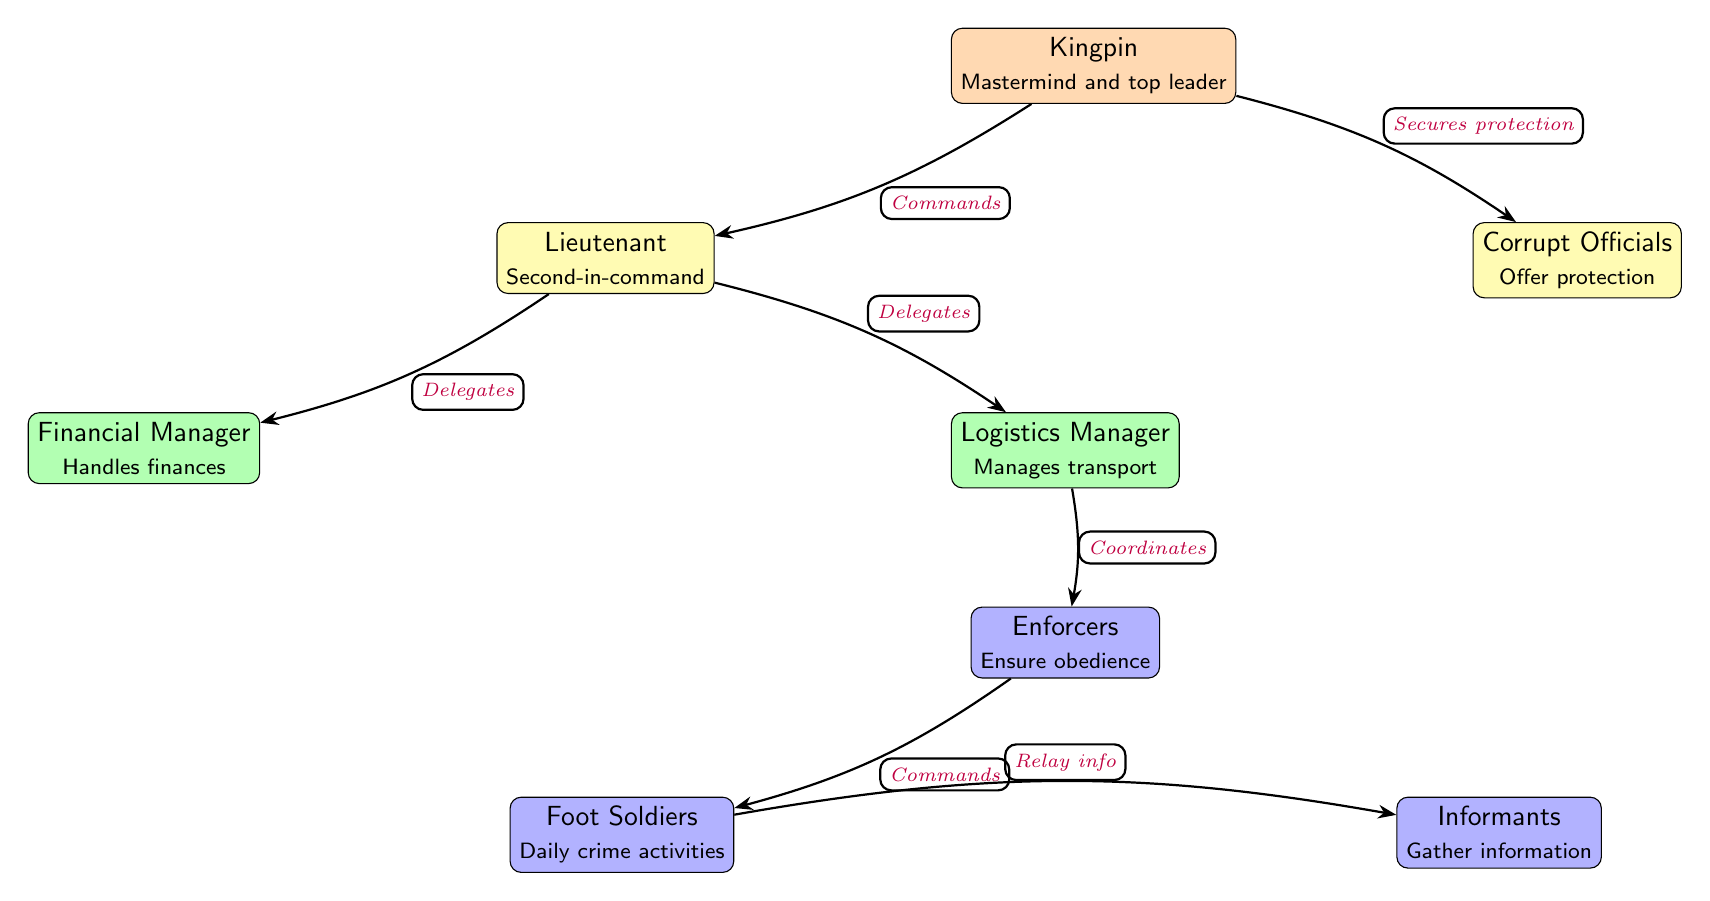What is the top position in the hierarchy? The top position is represented by the "Kingpin," who is the mastermind and top leader of the criminal organization.
Answer: Kingpin How many levels are in the hierarchy? The diagram shows four distinct levels: the Kingpin at level 1, Lieutenants and Corrupt Officials at level 2, Financial and Logistics Managers at level 3, and Enforcers, Foot Soldiers, and Informants at level 4.
Answer: 4 Which role is responsible for handling finances? The "Financial Manager" is responsible for handling finances within the organization, placed at level 3 below the Lieutenant.
Answer: Financial Manager Who does the Lieutenant delegate tasks to? The Lieutenant delegates tasks to both the "Financial Manager" and the "Logistics Manager," coordinating the execution of financial and logistical aspects of the organization.
Answer: Financial Manager and Logistics Manager What is the relationship between the Kingpin and the Corrupt Officials? The Kingpin secures protection by collaborating with the Corrupt Officials, which ensures the organization has cover and safety from law enforcement.
Answer: Secures protection Which role commands the Foot Soldiers? The "Enforcers" command the Foot Soldiers, as illustrated in the flow of the diagram where the enforcers ensure obedience and manage the activities of the foot soldiers.
Answer: Enforcers How does information flow from the Foot Soldiers? The information from the Foot Soldiers is relayed to the Informants, who are responsible for gathering intelligence for the organization.
Answer: Relay info What is the purpose of the Corrupt Officials in the hierarchy? The Corrupt Officials serve the purpose of offering protection to the criminal organization, which is crucial for their operations.
Answer: Offer protection Which role is directly below the Kingpin? Directly below the Kingpin in the hierarchy are the Lieutenants, who act as second-in-command and help manage the organization.
Answer: Lieutenant 